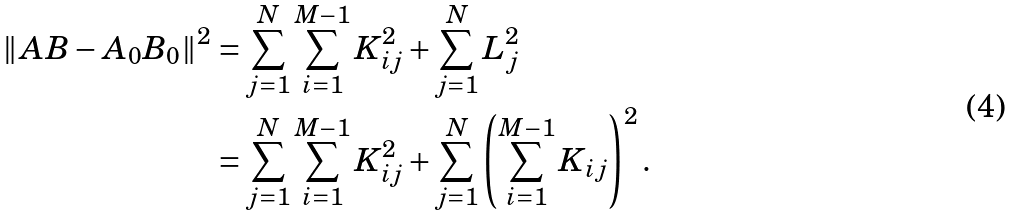Convert formula to latex. <formula><loc_0><loc_0><loc_500><loc_500>\| A B - A _ { 0 } B _ { 0 } \| ^ { 2 } & = \sum _ { j = 1 } ^ { N } \sum _ { i = 1 } ^ { M - 1 } K _ { i j } ^ { 2 } + \sum _ { j = 1 } ^ { N } L _ { j } ^ { 2 } \\ & = \sum _ { j = 1 } ^ { N } \sum _ { i = 1 } ^ { M - 1 } K _ { i j } ^ { 2 } + \sum _ { j = 1 } ^ { N } \left ( \sum _ { i = 1 } ^ { M - 1 } K _ { i j } \right ) ^ { 2 } .</formula> 